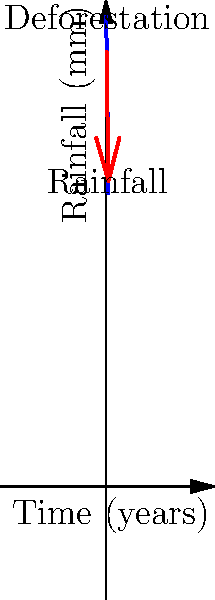Based on the weather map showing rainfall patterns over time in a deforested area, what is the approximate percentage decrease in rainfall after 5 years of deforestation? To calculate the percentage decrease in rainfall after 5 years of deforestation:

1. Identify initial rainfall: 1000 mm (at year 0)
2. Identify final rainfall: 625 mm (at year 5)
3. Calculate the decrease: 1000 mm - 625 mm = 375 mm
4. Calculate the percentage decrease:
   $\frac{\text{Decrease}}{\text{Initial Value}} \times 100\% = \frac{375}{1000} \times 100\% = 37.5\%$

The graph shows a clear downward trend in rainfall as deforestation progresses over the 5-year period. This decrease in rainfall could potentially impact crop yields and water availability for farming activities.
Answer: 37.5% 